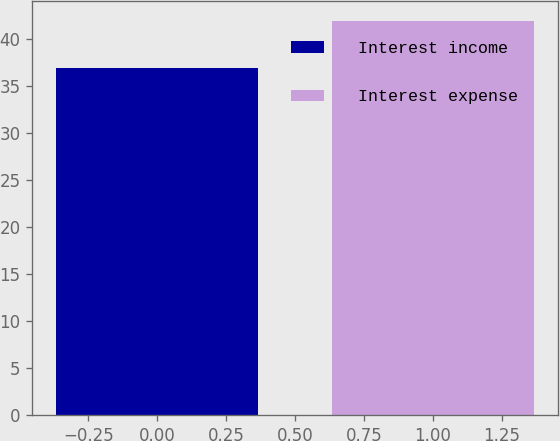Convert chart. <chart><loc_0><loc_0><loc_500><loc_500><bar_chart><fcel>Interest income<fcel>Interest expense<nl><fcel>37<fcel>42<nl></chart> 